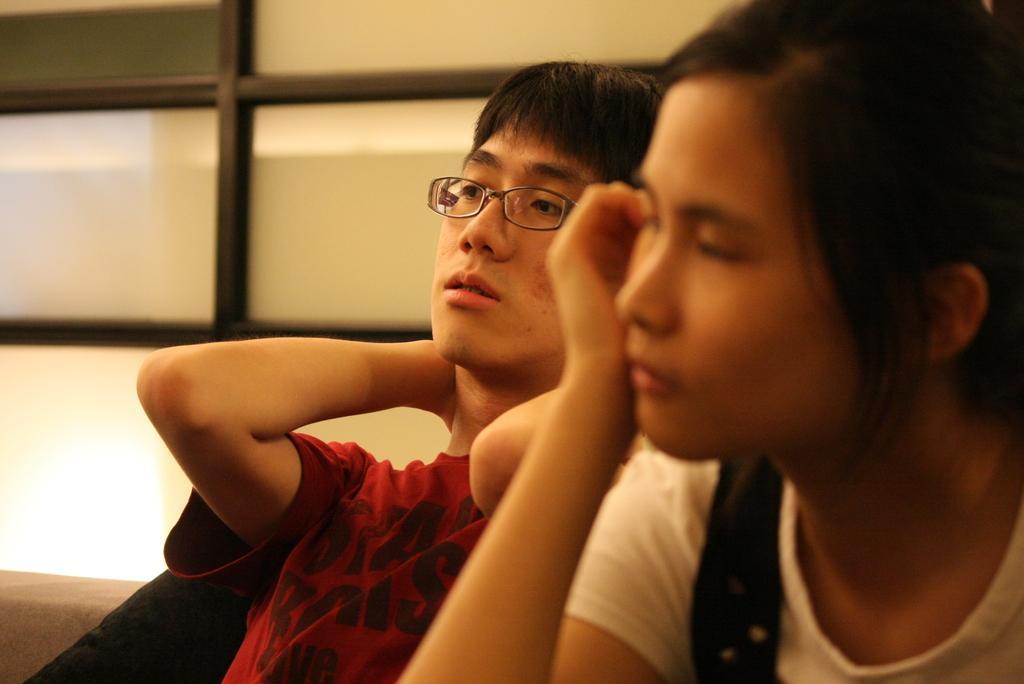Could you give a brief overview of what you see in this image? In this image we can see a man and a woman sitting. On the backside we can see a window. 